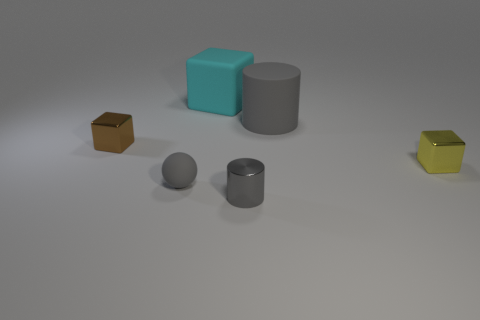What material is the object behind the large gray rubber thing?
Ensure brevity in your answer.  Rubber. There is a shiny cylinder that is the same color as the small ball; what size is it?
Give a very brief answer. Small. What is the color of the metal cube that is right of the shiny block on the left side of the gray cylinder behind the yellow thing?
Ensure brevity in your answer.  Yellow. There is a block behind the small shiny thing that is left of the gray matte sphere; what is its size?
Your answer should be very brief. Large. What is the tiny thing that is behind the gray metallic cylinder and to the right of the gray rubber sphere made of?
Your response must be concise. Metal. There is a yellow object; is its size the same as the rubber object on the right side of the cyan cube?
Your answer should be compact. No. Are any gray rubber spheres visible?
Ensure brevity in your answer.  Yes. There is another big gray thing that is the same shape as the gray metallic thing; what is it made of?
Your answer should be very brief. Rubber. How big is the metal cube that is behind the small shiny block that is on the right side of the tiny block to the left of the tiny yellow shiny thing?
Your answer should be compact. Small. Are there any things in front of the small cylinder?
Ensure brevity in your answer.  No. 